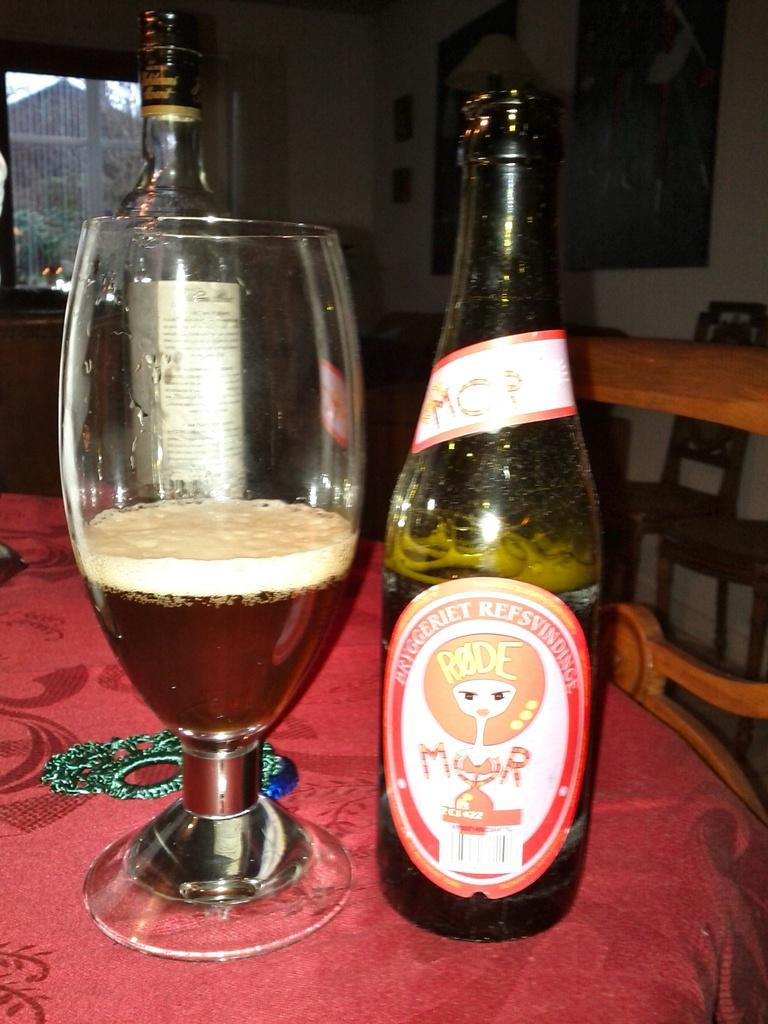<image>
Give a short and clear explanation of the subsequent image. Bottle of rode beer that is poured in a wine glass 